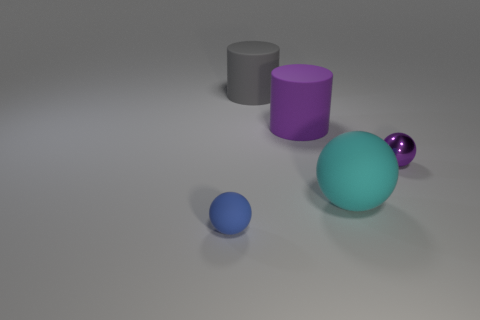There is a matte object that is the same color as the small metal sphere; what is its size?
Ensure brevity in your answer.  Large. Is the number of tiny metallic objects less than the number of purple matte spheres?
Offer a very short reply. No. There is a purple matte cylinder; does it have the same size as the ball behind the cyan thing?
Provide a succinct answer. No. What is the color of the ball in front of the matte ball that is right of the gray rubber cylinder?
Give a very brief answer. Blue. How many things are either big things that are behind the large cyan matte object or spheres that are on the left side of the metal ball?
Provide a short and direct response. 4. Is the size of the cyan matte ball the same as the gray cylinder?
Offer a terse response. Yes. Do the tiny thing that is on the right side of the tiny blue rubber ball and the matte object that is in front of the cyan ball have the same shape?
Your response must be concise. Yes. What size is the purple ball?
Keep it short and to the point. Small. What is the material of the large thing in front of the cylinder that is in front of the big gray rubber object that is to the left of the large purple cylinder?
Your answer should be compact. Rubber. What number of other objects are there of the same color as the big rubber ball?
Make the answer very short. 0. 